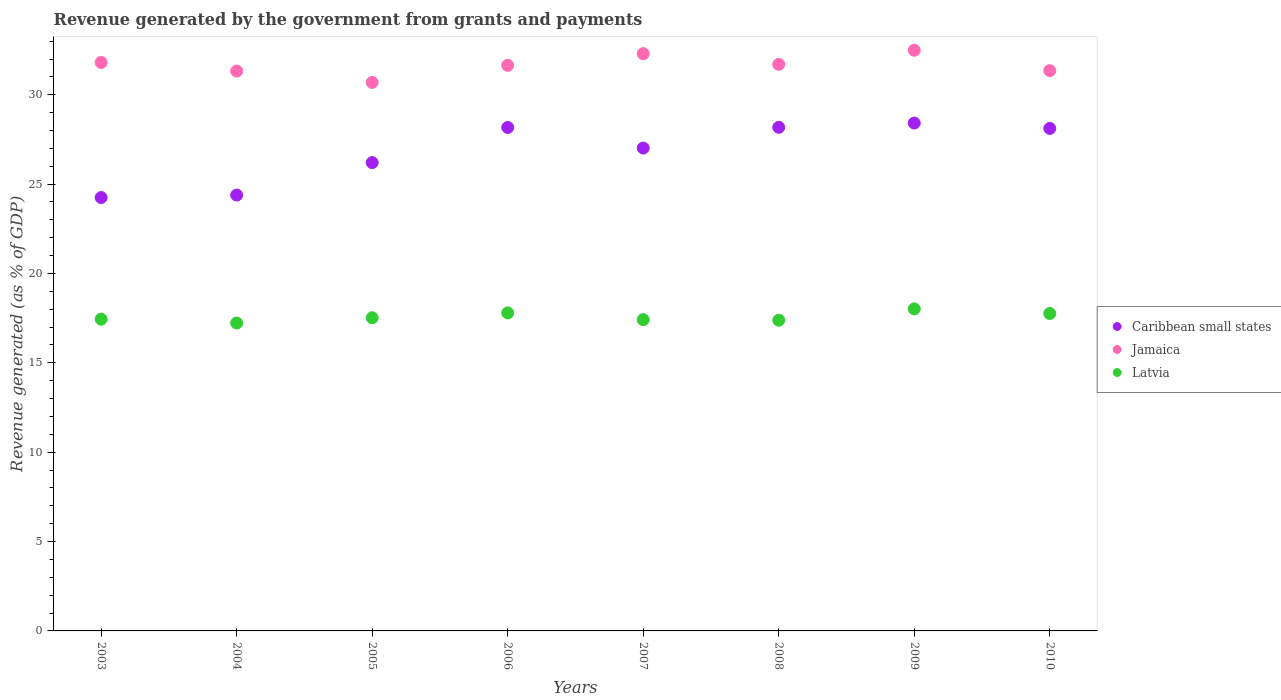How many different coloured dotlines are there?
Provide a short and direct response. 3. What is the revenue generated by the government in Jamaica in 2005?
Your answer should be compact. 30.69. Across all years, what is the maximum revenue generated by the government in Jamaica?
Keep it short and to the point. 32.49. Across all years, what is the minimum revenue generated by the government in Jamaica?
Your answer should be very brief. 30.69. In which year was the revenue generated by the government in Latvia minimum?
Your answer should be very brief. 2004. What is the total revenue generated by the government in Caribbean small states in the graph?
Keep it short and to the point. 214.74. What is the difference between the revenue generated by the government in Jamaica in 2007 and that in 2008?
Make the answer very short. 0.6. What is the difference between the revenue generated by the government in Jamaica in 2004 and the revenue generated by the government in Latvia in 2005?
Your answer should be very brief. 13.8. What is the average revenue generated by the government in Caribbean small states per year?
Your response must be concise. 26.84. In the year 2009, what is the difference between the revenue generated by the government in Caribbean small states and revenue generated by the government in Jamaica?
Make the answer very short. -4.08. What is the ratio of the revenue generated by the government in Latvia in 2005 to that in 2007?
Give a very brief answer. 1.01. Is the revenue generated by the government in Latvia in 2004 less than that in 2010?
Keep it short and to the point. Yes. What is the difference between the highest and the second highest revenue generated by the government in Jamaica?
Give a very brief answer. 0.19. What is the difference between the highest and the lowest revenue generated by the government in Latvia?
Your answer should be compact. 0.79. Does the revenue generated by the government in Latvia monotonically increase over the years?
Provide a succinct answer. No. Is the revenue generated by the government in Jamaica strictly less than the revenue generated by the government in Latvia over the years?
Your answer should be compact. No. Are the values on the major ticks of Y-axis written in scientific E-notation?
Make the answer very short. No. Does the graph contain any zero values?
Give a very brief answer. No. Does the graph contain grids?
Your answer should be very brief. No. Where does the legend appear in the graph?
Keep it short and to the point. Center right. How many legend labels are there?
Offer a very short reply. 3. How are the legend labels stacked?
Keep it short and to the point. Vertical. What is the title of the graph?
Provide a succinct answer. Revenue generated by the government from grants and payments. What is the label or title of the X-axis?
Offer a very short reply. Years. What is the label or title of the Y-axis?
Make the answer very short. Revenue generated (as % of GDP). What is the Revenue generated (as % of GDP) in Caribbean small states in 2003?
Give a very brief answer. 24.25. What is the Revenue generated (as % of GDP) in Jamaica in 2003?
Provide a succinct answer. 31.81. What is the Revenue generated (as % of GDP) of Latvia in 2003?
Offer a terse response. 17.44. What is the Revenue generated (as % of GDP) in Caribbean small states in 2004?
Keep it short and to the point. 24.39. What is the Revenue generated (as % of GDP) in Jamaica in 2004?
Your answer should be very brief. 31.33. What is the Revenue generated (as % of GDP) in Latvia in 2004?
Give a very brief answer. 17.23. What is the Revenue generated (as % of GDP) of Caribbean small states in 2005?
Offer a very short reply. 26.2. What is the Revenue generated (as % of GDP) of Jamaica in 2005?
Offer a very short reply. 30.69. What is the Revenue generated (as % of GDP) of Latvia in 2005?
Offer a terse response. 17.52. What is the Revenue generated (as % of GDP) in Caribbean small states in 2006?
Your answer should be very brief. 28.17. What is the Revenue generated (as % of GDP) in Jamaica in 2006?
Ensure brevity in your answer.  31.65. What is the Revenue generated (as % of GDP) in Latvia in 2006?
Provide a succinct answer. 17.8. What is the Revenue generated (as % of GDP) of Caribbean small states in 2007?
Keep it short and to the point. 27.02. What is the Revenue generated (as % of GDP) in Jamaica in 2007?
Keep it short and to the point. 32.3. What is the Revenue generated (as % of GDP) of Latvia in 2007?
Keep it short and to the point. 17.42. What is the Revenue generated (as % of GDP) of Caribbean small states in 2008?
Ensure brevity in your answer.  28.18. What is the Revenue generated (as % of GDP) in Jamaica in 2008?
Your answer should be compact. 31.7. What is the Revenue generated (as % of GDP) in Latvia in 2008?
Give a very brief answer. 17.38. What is the Revenue generated (as % of GDP) in Caribbean small states in 2009?
Your answer should be very brief. 28.42. What is the Revenue generated (as % of GDP) of Jamaica in 2009?
Give a very brief answer. 32.49. What is the Revenue generated (as % of GDP) of Latvia in 2009?
Give a very brief answer. 18.02. What is the Revenue generated (as % of GDP) in Caribbean small states in 2010?
Keep it short and to the point. 28.12. What is the Revenue generated (as % of GDP) in Jamaica in 2010?
Make the answer very short. 31.35. What is the Revenue generated (as % of GDP) of Latvia in 2010?
Make the answer very short. 17.76. Across all years, what is the maximum Revenue generated (as % of GDP) of Caribbean small states?
Provide a short and direct response. 28.42. Across all years, what is the maximum Revenue generated (as % of GDP) in Jamaica?
Ensure brevity in your answer.  32.49. Across all years, what is the maximum Revenue generated (as % of GDP) of Latvia?
Your answer should be very brief. 18.02. Across all years, what is the minimum Revenue generated (as % of GDP) of Caribbean small states?
Provide a short and direct response. 24.25. Across all years, what is the minimum Revenue generated (as % of GDP) in Jamaica?
Offer a very short reply. 30.69. Across all years, what is the minimum Revenue generated (as % of GDP) in Latvia?
Provide a short and direct response. 17.23. What is the total Revenue generated (as % of GDP) of Caribbean small states in the graph?
Provide a short and direct response. 214.74. What is the total Revenue generated (as % of GDP) of Jamaica in the graph?
Make the answer very short. 253.31. What is the total Revenue generated (as % of GDP) of Latvia in the graph?
Your answer should be compact. 140.57. What is the difference between the Revenue generated (as % of GDP) in Caribbean small states in 2003 and that in 2004?
Provide a short and direct response. -0.14. What is the difference between the Revenue generated (as % of GDP) of Jamaica in 2003 and that in 2004?
Your response must be concise. 0.48. What is the difference between the Revenue generated (as % of GDP) in Latvia in 2003 and that in 2004?
Offer a very short reply. 0.22. What is the difference between the Revenue generated (as % of GDP) in Caribbean small states in 2003 and that in 2005?
Provide a short and direct response. -1.96. What is the difference between the Revenue generated (as % of GDP) of Jamaica in 2003 and that in 2005?
Make the answer very short. 1.12. What is the difference between the Revenue generated (as % of GDP) in Latvia in 2003 and that in 2005?
Provide a short and direct response. -0.08. What is the difference between the Revenue generated (as % of GDP) of Caribbean small states in 2003 and that in 2006?
Offer a terse response. -3.92. What is the difference between the Revenue generated (as % of GDP) of Jamaica in 2003 and that in 2006?
Your answer should be very brief. 0.16. What is the difference between the Revenue generated (as % of GDP) in Latvia in 2003 and that in 2006?
Your answer should be very brief. -0.35. What is the difference between the Revenue generated (as % of GDP) of Caribbean small states in 2003 and that in 2007?
Your answer should be compact. -2.77. What is the difference between the Revenue generated (as % of GDP) of Jamaica in 2003 and that in 2007?
Make the answer very short. -0.49. What is the difference between the Revenue generated (as % of GDP) of Latvia in 2003 and that in 2007?
Give a very brief answer. 0.03. What is the difference between the Revenue generated (as % of GDP) of Caribbean small states in 2003 and that in 2008?
Make the answer very short. -3.93. What is the difference between the Revenue generated (as % of GDP) in Jamaica in 2003 and that in 2008?
Give a very brief answer. 0.11. What is the difference between the Revenue generated (as % of GDP) in Latvia in 2003 and that in 2008?
Your response must be concise. 0.06. What is the difference between the Revenue generated (as % of GDP) in Caribbean small states in 2003 and that in 2009?
Keep it short and to the point. -4.17. What is the difference between the Revenue generated (as % of GDP) of Jamaica in 2003 and that in 2009?
Give a very brief answer. -0.68. What is the difference between the Revenue generated (as % of GDP) in Latvia in 2003 and that in 2009?
Offer a terse response. -0.58. What is the difference between the Revenue generated (as % of GDP) of Caribbean small states in 2003 and that in 2010?
Offer a terse response. -3.87. What is the difference between the Revenue generated (as % of GDP) in Jamaica in 2003 and that in 2010?
Offer a very short reply. 0.46. What is the difference between the Revenue generated (as % of GDP) of Latvia in 2003 and that in 2010?
Offer a very short reply. -0.32. What is the difference between the Revenue generated (as % of GDP) in Caribbean small states in 2004 and that in 2005?
Give a very brief answer. -1.82. What is the difference between the Revenue generated (as % of GDP) of Jamaica in 2004 and that in 2005?
Your answer should be very brief. 0.64. What is the difference between the Revenue generated (as % of GDP) in Latvia in 2004 and that in 2005?
Your answer should be very brief. -0.29. What is the difference between the Revenue generated (as % of GDP) in Caribbean small states in 2004 and that in 2006?
Make the answer very short. -3.78. What is the difference between the Revenue generated (as % of GDP) in Jamaica in 2004 and that in 2006?
Provide a succinct answer. -0.32. What is the difference between the Revenue generated (as % of GDP) of Latvia in 2004 and that in 2006?
Offer a terse response. -0.57. What is the difference between the Revenue generated (as % of GDP) in Caribbean small states in 2004 and that in 2007?
Give a very brief answer. -2.63. What is the difference between the Revenue generated (as % of GDP) of Jamaica in 2004 and that in 2007?
Offer a very short reply. -0.97. What is the difference between the Revenue generated (as % of GDP) in Latvia in 2004 and that in 2007?
Provide a succinct answer. -0.19. What is the difference between the Revenue generated (as % of GDP) of Caribbean small states in 2004 and that in 2008?
Provide a succinct answer. -3.79. What is the difference between the Revenue generated (as % of GDP) of Jamaica in 2004 and that in 2008?
Offer a terse response. -0.38. What is the difference between the Revenue generated (as % of GDP) in Latvia in 2004 and that in 2008?
Keep it short and to the point. -0.16. What is the difference between the Revenue generated (as % of GDP) in Caribbean small states in 2004 and that in 2009?
Provide a succinct answer. -4.03. What is the difference between the Revenue generated (as % of GDP) in Jamaica in 2004 and that in 2009?
Your response must be concise. -1.17. What is the difference between the Revenue generated (as % of GDP) of Latvia in 2004 and that in 2009?
Make the answer very short. -0.79. What is the difference between the Revenue generated (as % of GDP) in Caribbean small states in 2004 and that in 2010?
Your response must be concise. -3.73. What is the difference between the Revenue generated (as % of GDP) in Jamaica in 2004 and that in 2010?
Offer a terse response. -0.02. What is the difference between the Revenue generated (as % of GDP) in Latvia in 2004 and that in 2010?
Your response must be concise. -0.53. What is the difference between the Revenue generated (as % of GDP) of Caribbean small states in 2005 and that in 2006?
Make the answer very short. -1.97. What is the difference between the Revenue generated (as % of GDP) of Jamaica in 2005 and that in 2006?
Provide a succinct answer. -0.96. What is the difference between the Revenue generated (as % of GDP) in Latvia in 2005 and that in 2006?
Make the answer very short. -0.27. What is the difference between the Revenue generated (as % of GDP) of Caribbean small states in 2005 and that in 2007?
Your answer should be compact. -0.81. What is the difference between the Revenue generated (as % of GDP) of Jamaica in 2005 and that in 2007?
Keep it short and to the point. -1.61. What is the difference between the Revenue generated (as % of GDP) of Latvia in 2005 and that in 2007?
Offer a very short reply. 0.1. What is the difference between the Revenue generated (as % of GDP) of Caribbean small states in 2005 and that in 2008?
Provide a short and direct response. -1.97. What is the difference between the Revenue generated (as % of GDP) of Jamaica in 2005 and that in 2008?
Offer a terse response. -1.01. What is the difference between the Revenue generated (as % of GDP) in Latvia in 2005 and that in 2008?
Your answer should be compact. 0.14. What is the difference between the Revenue generated (as % of GDP) of Caribbean small states in 2005 and that in 2009?
Make the answer very short. -2.21. What is the difference between the Revenue generated (as % of GDP) of Jamaica in 2005 and that in 2009?
Your answer should be very brief. -1.8. What is the difference between the Revenue generated (as % of GDP) in Latvia in 2005 and that in 2009?
Your response must be concise. -0.5. What is the difference between the Revenue generated (as % of GDP) of Caribbean small states in 2005 and that in 2010?
Your response must be concise. -1.91. What is the difference between the Revenue generated (as % of GDP) in Jamaica in 2005 and that in 2010?
Provide a succinct answer. -0.66. What is the difference between the Revenue generated (as % of GDP) in Latvia in 2005 and that in 2010?
Ensure brevity in your answer.  -0.24. What is the difference between the Revenue generated (as % of GDP) in Caribbean small states in 2006 and that in 2007?
Your answer should be compact. 1.15. What is the difference between the Revenue generated (as % of GDP) in Jamaica in 2006 and that in 2007?
Your response must be concise. -0.65. What is the difference between the Revenue generated (as % of GDP) in Latvia in 2006 and that in 2007?
Provide a short and direct response. 0.38. What is the difference between the Revenue generated (as % of GDP) in Caribbean small states in 2006 and that in 2008?
Provide a succinct answer. -0.01. What is the difference between the Revenue generated (as % of GDP) in Jamaica in 2006 and that in 2008?
Ensure brevity in your answer.  -0.06. What is the difference between the Revenue generated (as % of GDP) in Latvia in 2006 and that in 2008?
Ensure brevity in your answer.  0.41. What is the difference between the Revenue generated (as % of GDP) of Caribbean small states in 2006 and that in 2009?
Make the answer very short. -0.25. What is the difference between the Revenue generated (as % of GDP) of Jamaica in 2006 and that in 2009?
Make the answer very short. -0.85. What is the difference between the Revenue generated (as % of GDP) of Latvia in 2006 and that in 2009?
Offer a very short reply. -0.22. What is the difference between the Revenue generated (as % of GDP) in Caribbean small states in 2006 and that in 2010?
Keep it short and to the point. 0.05. What is the difference between the Revenue generated (as % of GDP) of Jamaica in 2006 and that in 2010?
Keep it short and to the point. 0.3. What is the difference between the Revenue generated (as % of GDP) of Latvia in 2006 and that in 2010?
Ensure brevity in your answer.  0.03. What is the difference between the Revenue generated (as % of GDP) of Caribbean small states in 2007 and that in 2008?
Your answer should be very brief. -1.16. What is the difference between the Revenue generated (as % of GDP) in Jamaica in 2007 and that in 2008?
Give a very brief answer. 0.6. What is the difference between the Revenue generated (as % of GDP) in Latvia in 2007 and that in 2008?
Your answer should be very brief. 0.03. What is the difference between the Revenue generated (as % of GDP) in Caribbean small states in 2007 and that in 2009?
Offer a terse response. -1.4. What is the difference between the Revenue generated (as % of GDP) of Jamaica in 2007 and that in 2009?
Keep it short and to the point. -0.19. What is the difference between the Revenue generated (as % of GDP) in Latvia in 2007 and that in 2009?
Ensure brevity in your answer.  -0.6. What is the difference between the Revenue generated (as % of GDP) in Caribbean small states in 2007 and that in 2010?
Make the answer very short. -1.1. What is the difference between the Revenue generated (as % of GDP) in Jamaica in 2007 and that in 2010?
Your response must be concise. 0.95. What is the difference between the Revenue generated (as % of GDP) of Latvia in 2007 and that in 2010?
Offer a terse response. -0.35. What is the difference between the Revenue generated (as % of GDP) in Caribbean small states in 2008 and that in 2009?
Provide a succinct answer. -0.24. What is the difference between the Revenue generated (as % of GDP) of Jamaica in 2008 and that in 2009?
Offer a terse response. -0.79. What is the difference between the Revenue generated (as % of GDP) in Latvia in 2008 and that in 2009?
Offer a terse response. -0.64. What is the difference between the Revenue generated (as % of GDP) of Caribbean small states in 2008 and that in 2010?
Provide a short and direct response. 0.06. What is the difference between the Revenue generated (as % of GDP) of Jamaica in 2008 and that in 2010?
Keep it short and to the point. 0.35. What is the difference between the Revenue generated (as % of GDP) of Latvia in 2008 and that in 2010?
Ensure brevity in your answer.  -0.38. What is the difference between the Revenue generated (as % of GDP) in Caribbean small states in 2009 and that in 2010?
Your answer should be compact. 0.3. What is the difference between the Revenue generated (as % of GDP) in Jamaica in 2009 and that in 2010?
Your answer should be very brief. 1.14. What is the difference between the Revenue generated (as % of GDP) in Latvia in 2009 and that in 2010?
Provide a succinct answer. 0.26. What is the difference between the Revenue generated (as % of GDP) in Caribbean small states in 2003 and the Revenue generated (as % of GDP) in Jamaica in 2004?
Provide a succinct answer. -7.08. What is the difference between the Revenue generated (as % of GDP) of Caribbean small states in 2003 and the Revenue generated (as % of GDP) of Latvia in 2004?
Give a very brief answer. 7.02. What is the difference between the Revenue generated (as % of GDP) of Jamaica in 2003 and the Revenue generated (as % of GDP) of Latvia in 2004?
Provide a short and direct response. 14.58. What is the difference between the Revenue generated (as % of GDP) in Caribbean small states in 2003 and the Revenue generated (as % of GDP) in Jamaica in 2005?
Your response must be concise. -6.44. What is the difference between the Revenue generated (as % of GDP) of Caribbean small states in 2003 and the Revenue generated (as % of GDP) of Latvia in 2005?
Provide a short and direct response. 6.73. What is the difference between the Revenue generated (as % of GDP) in Jamaica in 2003 and the Revenue generated (as % of GDP) in Latvia in 2005?
Your answer should be compact. 14.29. What is the difference between the Revenue generated (as % of GDP) in Caribbean small states in 2003 and the Revenue generated (as % of GDP) in Jamaica in 2006?
Give a very brief answer. -7.4. What is the difference between the Revenue generated (as % of GDP) in Caribbean small states in 2003 and the Revenue generated (as % of GDP) in Latvia in 2006?
Make the answer very short. 6.45. What is the difference between the Revenue generated (as % of GDP) of Jamaica in 2003 and the Revenue generated (as % of GDP) of Latvia in 2006?
Your response must be concise. 14.01. What is the difference between the Revenue generated (as % of GDP) in Caribbean small states in 2003 and the Revenue generated (as % of GDP) in Jamaica in 2007?
Provide a short and direct response. -8.05. What is the difference between the Revenue generated (as % of GDP) in Caribbean small states in 2003 and the Revenue generated (as % of GDP) in Latvia in 2007?
Offer a terse response. 6.83. What is the difference between the Revenue generated (as % of GDP) of Jamaica in 2003 and the Revenue generated (as % of GDP) of Latvia in 2007?
Ensure brevity in your answer.  14.39. What is the difference between the Revenue generated (as % of GDP) in Caribbean small states in 2003 and the Revenue generated (as % of GDP) in Jamaica in 2008?
Offer a terse response. -7.45. What is the difference between the Revenue generated (as % of GDP) of Caribbean small states in 2003 and the Revenue generated (as % of GDP) of Latvia in 2008?
Provide a succinct answer. 6.86. What is the difference between the Revenue generated (as % of GDP) of Jamaica in 2003 and the Revenue generated (as % of GDP) of Latvia in 2008?
Provide a succinct answer. 14.42. What is the difference between the Revenue generated (as % of GDP) in Caribbean small states in 2003 and the Revenue generated (as % of GDP) in Jamaica in 2009?
Provide a succinct answer. -8.24. What is the difference between the Revenue generated (as % of GDP) in Caribbean small states in 2003 and the Revenue generated (as % of GDP) in Latvia in 2009?
Your answer should be very brief. 6.23. What is the difference between the Revenue generated (as % of GDP) of Jamaica in 2003 and the Revenue generated (as % of GDP) of Latvia in 2009?
Provide a short and direct response. 13.79. What is the difference between the Revenue generated (as % of GDP) in Caribbean small states in 2003 and the Revenue generated (as % of GDP) in Jamaica in 2010?
Give a very brief answer. -7.1. What is the difference between the Revenue generated (as % of GDP) in Caribbean small states in 2003 and the Revenue generated (as % of GDP) in Latvia in 2010?
Offer a terse response. 6.49. What is the difference between the Revenue generated (as % of GDP) in Jamaica in 2003 and the Revenue generated (as % of GDP) in Latvia in 2010?
Make the answer very short. 14.05. What is the difference between the Revenue generated (as % of GDP) of Caribbean small states in 2004 and the Revenue generated (as % of GDP) of Jamaica in 2005?
Keep it short and to the point. -6.3. What is the difference between the Revenue generated (as % of GDP) of Caribbean small states in 2004 and the Revenue generated (as % of GDP) of Latvia in 2005?
Your answer should be very brief. 6.87. What is the difference between the Revenue generated (as % of GDP) in Jamaica in 2004 and the Revenue generated (as % of GDP) in Latvia in 2005?
Your answer should be very brief. 13.8. What is the difference between the Revenue generated (as % of GDP) in Caribbean small states in 2004 and the Revenue generated (as % of GDP) in Jamaica in 2006?
Make the answer very short. -7.26. What is the difference between the Revenue generated (as % of GDP) of Caribbean small states in 2004 and the Revenue generated (as % of GDP) of Latvia in 2006?
Keep it short and to the point. 6.59. What is the difference between the Revenue generated (as % of GDP) in Jamaica in 2004 and the Revenue generated (as % of GDP) in Latvia in 2006?
Your response must be concise. 13.53. What is the difference between the Revenue generated (as % of GDP) of Caribbean small states in 2004 and the Revenue generated (as % of GDP) of Jamaica in 2007?
Your answer should be compact. -7.91. What is the difference between the Revenue generated (as % of GDP) in Caribbean small states in 2004 and the Revenue generated (as % of GDP) in Latvia in 2007?
Give a very brief answer. 6.97. What is the difference between the Revenue generated (as % of GDP) in Jamaica in 2004 and the Revenue generated (as % of GDP) in Latvia in 2007?
Make the answer very short. 13.91. What is the difference between the Revenue generated (as % of GDP) in Caribbean small states in 2004 and the Revenue generated (as % of GDP) in Jamaica in 2008?
Make the answer very short. -7.31. What is the difference between the Revenue generated (as % of GDP) in Caribbean small states in 2004 and the Revenue generated (as % of GDP) in Latvia in 2008?
Your answer should be compact. 7. What is the difference between the Revenue generated (as % of GDP) of Jamaica in 2004 and the Revenue generated (as % of GDP) of Latvia in 2008?
Provide a succinct answer. 13.94. What is the difference between the Revenue generated (as % of GDP) of Caribbean small states in 2004 and the Revenue generated (as % of GDP) of Jamaica in 2009?
Keep it short and to the point. -8.1. What is the difference between the Revenue generated (as % of GDP) of Caribbean small states in 2004 and the Revenue generated (as % of GDP) of Latvia in 2009?
Give a very brief answer. 6.37. What is the difference between the Revenue generated (as % of GDP) in Jamaica in 2004 and the Revenue generated (as % of GDP) in Latvia in 2009?
Provide a succinct answer. 13.31. What is the difference between the Revenue generated (as % of GDP) of Caribbean small states in 2004 and the Revenue generated (as % of GDP) of Jamaica in 2010?
Give a very brief answer. -6.96. What is the difference between the Revenue generated (as % of GDP) in Caribbean small states in 2004 and the Revenue generated (as % of GDP) in Latvia in 2010?
Your answer should be very brief. 6.63. What is the difference between the Revenue generated (as % of GDP) in Jamaica in 2004 and the Revenue generated (as % of GDP) in Latvia in 2010?
Make the answer very short. 13.56. What is the difference between the Revenue generated (as % of GDP) of Caribbean small states in 2005 and the Revenue generated (as % of GDP) of Jamaica in 2006?
Offer a very short reply. -5.44. What is the difference between the Revenue generated (as % of GDP) of Caribbean small states in 2005 and the Revenue generated (as % of GDP) of Latvia in 2006?
Provide a short and direct response. 8.41. What is the difference between the Revenue generated (as % of GDP) of Jamaica in 2005 and the Revenue generated (as % of GDP) of Latvia in 2006?
Make the answer very short. 12.89. What is the difference between the Revenue generated (as % of GDP) in Caribbean small states in 2005 and the Revenue generated (as % of GDP) in Jamaica in 2007?
Your answer should be compact. -6.1. What is the difference between the Revenue generated (as % of GDP) of Caribbean small states in 2005 and the Revenue generated (as % of GDP) of Latvia in 2007?
Keep it short and to the point. 8.79. What is the difference between the Revenue generated (as % of GDP) in Jamaica in 2005 and the Revenue generated (as % of GDP) in Latvia in 2007?
Keep it short and to the point. 13.27. What is the difference between the Revenue generated (as % of GDP) in Caribbean small states in 2005 and the Revenue generated (as % of GDP) in Jamaica in 2008?
Offer a very short reply. -5.5. What is the difference between the Revenue generated (as % of GDP) of Caribbean small states in 2005 and the Revenue generated (as % of GDP) of Latvia in 2008?
Keep it short and to the point. 8.82. What is the difference between the Revenue generated (as % of GDP) in Jamaica in 2005 and the Revenue generated (as % of GDP) in Latvia in 2008?
Offer a terse response. 13.31. What is the difference between the Revenue generated (as % of GDP) in Caribbean small states in 2005 and the Revenue generated (as % of GDP) in Jamaica in 2009?
Offer a terse response. -6.29. What is the difference between the Revenue generated (as % of GDP) in Caribbean small states in 2005 and the Revenue generated (as % of GDP) in Latvia in 2009?
Your response must be concise. 8.18. What is the difference between the Revenue generated (as % of GDP) in Jamaica in 2005 and the Revenue generated (as % of GDP) in Latvia in 2009?
Offer a very short reply. 12.67. What is the difference between the Revenue generated (as % of GDP) of Caribbean small states in 2005 and the Revenue generated (as % of GDP) of Jamaica in 2010?
Keep it short and to the point. -5.14. What is the difference between the Revenue generated (as % of GDP) in Caribbean small states in 2005 and the Revenue generated (as % of GDP) in Latvia in 2010?
Ensure brevity in your answer.  8.44. What is the difference between the Revenue generated (as % of GDP) in Jamaica in 2005 and the Revenue generated (as % of GDP) in Latvia in 2010?
Your answer should be very brief. 12.93. What is the difference between the Revenue generated (as % of GDP) of Caribbean small states in 2006 and the Revenue generated (as % of GDP) of Jamaica in 2007?
Keep it short and to the point. -4.13. What is the difference between the Revenue generated (as % of GDP) in Caribbean small states in 2006 and the Revenue generated (as % of GDP) in Latvia in 2007?
Offer a terse response. 10.75. What is the difference between the Revenue generated (as % of GDP) in Jamaica in 2006 and the Revenue generated (as % of GDP) in Latvia in 2007?
Your response must be concise. 14.23. What is the difference between the Revenue generated (as % of GDP) in Caribbean small states in 2006 and the Revenue generated (as % of GDP) in Jamaica in 2008?
Provide a succinct answer. -3.53. What is the difference between the Revenue generated (as % of GDP) of Caribbean small states in 2006 and the Revenue generated (as % of GDP) of Latvia in 2008?
Keep it short and to the point. 10.79. What is the difference between the Revenue generated (as % of GDP) in Jamaica in 2006 and the Revenue generated (as % of GDP) in Latvia in 2008?
Your response must be concise. 14.26. What is the difference between the Revenue generated (as % of GDP) in Caribbean small states in 2006 and the Revenue generated (as % of GDP) in Jamaica in 2009?
Provide a short and direct response. -4.32. What is the difference between the Revenue generated (as % of GDP) in Caribbean small states in 2006 and the Revenue generated (as % of GDP) in Latvia in 2009?
Ensure brevity in your answer.  10.15. What is the difference between the Revenue generated (as % of GDP) of Jamaica in 2006 and the Revenue generated (as % of GDP) of Latvia in 2009?
Offer a terse response. 13.63. What is the difference between the Revenue generated (as % of GDP) in Caribbean small states in 2006 and the Revenue generated (as % of GDP) in Jamaica in 2010?
Offer a very short reply. -3.18. What is the difference between the Revenue generated (as % of GDP) in Caribbean small states in 2006 and the Revenue generated (as % of GDP) in Latvia in 2010?
Your answer should be compact. 10.41. What is the difference between the Revenue generated (as % of GDP) of Jamaica in 2006 and the Revenue generated (as % of GDP) of Latvia in 2010?
Provide a short and direct response. 13.88. What is the difference between the Revenue generated (as % of GDP) of Caribbean small states in 2007 and the Revenue generated (as % of GDP) of Jamaica in 2008?
Make the answer very short. -4.68. What is the difference between the Revenue generated (as % of GDP) in Caribbean small states in 2007 and the Revenue generated (as % of GDP) in Latvia in 2008?
Your answer should be compact. 9.63. What is the difference between the Revenue generated (as % of GDP) of Jamaica in 2007 and the Revenue generated (as % of GDP) of Latvia in 2008?
Offer a very short reply. 14.91. What is the difference between the Revenue generated (as % of GDP) in Caribbean small states in 2007 and the Revenue generated (as % of GDP) in Jamaica in 2009?
Provide a short and direct response. -5.47. What is the difference between the Revenue generated (as % of GDP) of Caribbean small states in 2007 and the Revenue generated (as % of GDP) of Latvia in 2009?
Provide a short and direct response. 9. What is the difference between the Revenue generated (as % of GDP) of Jamaica in 2007 and the Revenue generated (as % of GDP) of Latvia in 2009?
Make the answer very short. 14.28. What is the difference between the Revenue generated (as % of GDP) of Caribbean small states in 2007 and the Revenue generated (as % of GDP) of Jamaica in 2010?
Your answer should be very brief. -4.33. What is the difference between the Revenue generated (as % of GDP) of Caribbean small states in 2007 and the Revenue generated (as % of GDP) of Latvia in 2010?
Your response must be concise. 9.26. What is the difference between the Revenue generated (as % of GDP) in Jamaica in 2007 and the Revenue generated (as % of GDP) in Latvia in 2010?
Make the answer very short. 14.54. What is the difference between the Revenue generated (as % of GDP) of Caribbean small states in 2008 and the Revenue generated (as % of GDP) of Jamaica in 2009?
Your response must be concise. -4.31. What is the difference between the Revenue generated (as % of GDP) in Caribbean small states in 2008 and the Revenue generated (as % of GDP) in Latvia in 2009?
Make the answer very short. 10.16. What is the difference between the Revenue generated (as % of GDP) in Jamaica in 2008 and the Revenue generated (as % of GDP) in Latvia in 2009?
Provide a short and direct response. 13.68. What is the difference between the Revenue generated (as % of GDP) of Caribbean small states in 2008 and the Revenue generated (as % of GDP) of Jamaica in 2010?
Keep it short and to the point. -3.17. What is the difference between the Revenue generated (as % of GDP) in Caribbean small states in 2008 and the Revenue generated (as % of GDP) in Latvia in 2010?
Offer a very short reply. 10.42. What is the difference between the Revenue generated (as % of GDP) of Jamaica in 2008 and the Revenue generated (as % of GDP) of Latvia in 2010?
Your answer should be compact. 13.94. What is the difference between the Revenue generated (as % of GDP) of Caribbean small states in 2009 and the Revenue generated (as % of GDP) of Jamaica in 2010?
Your answer should be very brief. -2.93. What is the difference between the Revenue generated (as % of GDP) of Caribbean small states in 2009 and the Revenue generated (as % of GDP) of Latvia in 2010?
Your response must be concise. 10.65. What is the difference between the Revenue generated (as % of GDP) in Jamaica in 2009 and the Revenue generated (as % of GDP) in Latvia in 2010?
Ensure brevity in your answer.  14.73. What is the average Revenue generated (as % of GDP) of Caribbean small states per year?
Offer a terse response. 26.84. What is the average Revenue generated (as % of GDP) in Jamaica per year?
Your answer should be very brief. 31.66. What is the average Revenue generated (as % of GDP) in Latvia per year?
Keep it short and to the point. 17.57. In the year 2003, what is the difference between the Revenue generated (as % of GDP) in Caribbean small states and Revenue generated (as % of GDP) in Jamaica?
Your response must be concise. -7.56. In the year 2003, what is the difference between the Revenue generated (as % of GDP) in Caribbean small states and Revenue generated (as % of GDP) in Latvia?
Your response must be concise. 6.8. In the year 2003, what is the difference between the Revenue generated (as % of GDP) of Jamaica and Revenue generated (as % of GDP) of Latvia?
Provide a succinct answer. 14.36. In the year 2004, what is the difference between the Revenue generated (as % of GDP) of Caribbean small states and Revenue generated (as % of GDP) of Jamaica?
Your response must be concise. -6.94. In the year 2004, what is the difference between the Revenue generated (as % of GDP) in Caribbean small states and Revenue generated (as % of GDP) in Latvia?
Your response must be concise. 7.16. In the year 2004, what is the difference between the Revenue generated (as % of GDP) of Jamaica and Revenue generated (as % of GDP) of Latvia?
Ensure brevity in your answer.  14.1. In the year 2005, what is the difference between the Revenue generated (as % of GDP) of Caribbean small states and Revenue generated (as % of GDP) of Jamaica?
Keep it short and to the point. -4.49. In the year 2005, what is the difference between the Revenue generated (as % of GDP) of Caribbean small states and Revenue generated (as % of GDP) of Latvia?
Provide a succinct answer. 8.68. In the year 2005, what is the difference between the Revenue generated (as % of GDP) of Jamaica and Revenue generated (as % of GDP) of Latvia?
Give a very brief answer. 13.17. In the year 2006, what is the difference between the Revenue generated (as % of GDP) in Caribbean small states and Revenue generated (as % of GDP) in Jamaica?
Your response must be concise. -3.48. In the year 2006, what is the difference between the Revenue generated (as % of GDP) in Caribbean small states and Revenue generated (as % of GDP) in Latvia?
Make the answer very short. 10.38. In the year 2006, what is the difference between the Revenue generated (as % of GDP) in Jamaica and Revenue generated (as % of GDP) in Latvia?
Your answer should be very brief. 13.85. In the year 2007, what is the difference between the Revenue generated (as % of GDP) of Caribbean small states and Revenue generated (as % of GDP) of Jamaica?
Keep it short and to the point. -5.28. In the year 2007, what is the difference between the Revenue generated (as % of GDP) in Caribbean small states and Revenue generated (as % of GDP) in Latvia?
Offer a terse response. 9.6. In the year 2007, what is the difference between the Revenue generated (as % of GDP) of Jamaica and Revenue generated (as % of GDP) of Latvia?
Your answer should be compact. 14.88. In the year 2008, what is the difference between the Revenue generated (as % of GDP) in Caribbean small states and Revenue generated (as % of GDP) in Jamaica?
Your answer should be compact. -3.52. In the year 2008, what is the difference between the Revenue generated (as % of GDP) of Caribbean small states and Revenue generated (as % of GDP) of Latvia?
Make the answer very short. 10.79. In the year 2008, what is the difference between the Revenue generated (as % of GDP) of Jamaica and Revenue generated (as % of GDP) of Latvia?
Your answer should be compact. 14.32. In the year 2009, what is the difference between the Revenue generated (as % of GDP) of Caribbean small states and Revenue generated (as % of GDP) of Jamaica?
Offer a terse response. -4.08. In the year 2009, what is the difference between the Revenue generated (as % of GDP) of Caribbean small states and Revenue generated (as % of GDP) of Latvia?
Your response must be concise. 10.4. In the year 2009, what is the difference between the Revenue generated (as % of GDP) of Jamaica and Revenue generated (as % of GDP) of Latvia?
Give a very brief answer. 14.47. In the year 2010, what is the difference between the Revenue generated (as % of GDP) in Caribbean small states and Revenue generated (as % of GDP) in Jamaica?
Offer a terse response. -3.23. In the year 2010, what is the difference between the Revenue generated (as % of GDP) in Caribbean small states and Revenue generated (as % of GDP) in Latvia?
Provide a succinct answer. 10.35. In the year 2010, what is the difference between the Revenue generated (as % of GDP) of Jamaica and Revenue generated (as % of GDP) of Latvia?
Provide a short and direct response. 13.59. What is the ratio of the Revenue generated (as % of GDP) in Jamaica in 2003 to that in 2004?
Offer a very short reply. 1.02. What is the ratio of the Revenue generated (as % of GDP) of Latvia in 2003 to that in 2004?
Keep it short and to the point. 1.01. What is the ratio of the Revenue generated (as % of GDP) in Caribbean small states in 2003 to that in 2005?
Give a very brief answer. 0.93. What is the ratio of the Revenue generated (as % of GDP) of Jamaica in 2003 to that in 2005?
Offer a terse response. 1.04. What is the ratio of the Revenue generated (as % of GDP) of Caribbean small states in 2003 to that in 2006?
Provide a succinct answer. 0.86. What is the ratio of the Revenue generated (as % of GDP) in Latvia in 2003 to that in 2006?
Your answer should be compact. 0.98. What is the ratio of the Revenue generated (as % of GDP) of Caribbean small states in 2003 to that in 2007?
Provide a succinct answer. 0.9. What is the ratio of the Revenue generated (as % of GDP) of Caribbean small states in 2003 to that in 2008?
Your answer should be compact. 0.86. What is the ratio of the Revenue generated (as % of GDP) of Latvia in 2003 to that in 2008?
Make the answer very short. 1. What is the ratio of the Revenue generated (as % of GDP) in Caribbean small states in 2003 to that in 2009?
Your response must be concise. 0.85. What is the ratio of the Revenue generated (as % of GDP) in Jamaica in 2003 to that in 2009?
Keep it short and to the point. 0.98. What is the ratio of the Revenue generated (as % of GDP) in Caribbean small states in 2003 to that in 2010?
Offer a very short reply. 0.86. What is the ratio of the Revenue generated (as % of GDP) in Jamaica in 2003 to that in 2010?
Ensure brevity in your answer.  1.01. What is the ratio of the Revenue generated (as % of GDP) of Latvia in 2003 to that in 2010?
Keep it short and to the point. 0.98. What is the ratio of the Revenue generated (as % of GDP) of Caribbean small states in 2004 to that in 2005?
Give a very brief answer. 0.93. What is the ratio of the Revenue generated (as % of GDP) in Jamaica in 2004 to that in 2005?
Provide a succinct answer. 1.02. What is the ratio of the Revenue generated (as % of GDP) in Latvia in 2004 to that in 2005?
Give a very brief answer. 0.98. What is the ratio of the Revenue generated (as % of GDP) of Caribbean small states in 2004 to that in 2006?
Ensure brevity in your answer.  0.87. What is the ratio of the Revenue generated (as % of GDP) of Latvia in 2004 to that in 2006?
Provide a succinct answer. 0.97. What is the ratio of the Revenue generated (as % of GDP) of Caribbean small states in 2004 to that in 2007?
Keep it short and to the point. 0.9. What is the ratio of the Revenue generated (as % of GDP) of Jamaica in 2004 to that in 2007?
Give a very brief answer. 0.97. What is the ratio of the Revenue generated (as % of GDP) in Caribbean small states in 2004 to that in 2008?
Offer a terse response. 0.87. What is the ratio of the Revenue generated (as % of GDP) of Jamaica in 2004 to that in 2008?
Make the answer very short. 0.99. What is the ratio of the Revenue generated (as % of GDP) of Caribbean small states in 2004 to that in 2009?
Ensure brevity in your answer.  0.86. What is the ratio of the Revenue generated (as % of GDP) in Jamaica in 2004 to that in 2009?
Provide a succinct answer. 0.96. What is the ratio of the Revenue generated (as % of GDP) of Latvia in 2004 to that in 2009?
Offer a terse response. 0.96. What is the ratio of the Revenue generated (as % of GDP) of Caribbean small states in 2004 to that in 2010?
Give a very brief answer. 0.87. What is the ratio of the Revenue generated (as % of GDP) of Latvia in 2004 to that in 2010?
Your answer should be compact. 0.97. What is the ratio of the Revenue generated (as % of GDP) of Caribbean small states in 2005 to that in 2006?
Make the answer very short. 0.93. What is the ratio of the Revenue generated (as % of GDP) in Jamaica in 2005 to that in 2006?
Keep it short and to the point. 0.97. What is the ratio of the Revenue generated (as % of GDP) in Latvia in 2005 to that in 2006?
Provide a succinct answer. 0.98. What is the ratio of the Revenue generated (as % of GDP) of Caribbean small states in 2005 to that in 2007?
Offer a terse response. 0.97. What is the ratio of the Revenue generated (as % of GDP) of Jamaica in 2005 to that in 2007?
Make the answer very short. 0.95. What is the ratio of the Revenue generated (as % of GDP) of Latvia in 2005 to that in 2007?
Ensure brevity in your answer.  1.01. What is the ratio of the Revenue generated (as % of GDP) of Caribbean small states in 2005 to that in 2008?
Ensure brevity in your answer.  0.93. What is the ratio of the Revenue generated (as % of GDP) in Jamaica in 2005 to that in 2008?
Make the answer very short. 0.97. What is the ratio of the Revenue generated (as % of GDP) of Latvia in 2005 to that in 2008?
Make the answer very short. 1.01. What is the ratio of the Revenue generated (as % of GDP) in Caribbean small states in 2005 to that in 2009?
Make the answer very short. 0.92. What is the ratio of the Revenue generated (as % of GDP) in Jamaica in 2005 to that in 2009?
Provide a succinct answer. 0.94. What is the ratio of the Revenue generated (as % of GDP) in Latvia in 2005 to that in 2009?
Your response must be concise. 0.97. What is the ratio of the Revenue generated (as % of GDP) of Caribbean small states in 2005 to that in 2010?
Provide a short and direct response. 0.93. What is the ratio of the Revenue generated (as % of GDP) in Jamaica in 2005 to that in 2010?
Your answer should be compact. 0.98. What is the ratio of the Revenue generated (as % of GDP) of Latvia in 2005 to that in 2010?
Provide a succinct answer. 0.99. What is the ratio of the Revenue generated (as % of GDP) in Caribbean small states in 2006 to that in 2007?
Your answer should be very brief. 1.04. What is the ratio of the Revenue generated (as % of GDP) in Jamaica in 2006 to that in 2007?
Your answer should be very brief. 0.98. What is the ratio of the Revenue generated (as % of GDP) of Latvia in 2006 to that in 2007?
Your answer should be compact. 1.02. What is the ratio of the Revenue generated (as % of GDP) in Caribbean small states in 2006 to that in 2008?
Provide a succinct answer. 1. What is the ratio of the Revenue generated (as % of GDP) of Latvia in 2006 to that in 2008?
Your response must be concise. 1.02. What is the ratio of the Revenue generated (as % of GDP) of Caribbean small states in 2006 to that in 2009?
Your answer should be very brief. 0.99. What is the ratio of the Revenue generated (as % of GDP) of Jamaica in 2006 to that in 2009?
Offer a very short reply. 0.97. What is the ratio of the Revenue generated (as % of GDP) in Latvia in 2006 to that in 2009?
Give a very brief answer. 0.99. What is the ratio of the Revenue generated (as % of GDP) of Jamaica in 2006 to that in 2010?
Offer a terse response. 1.01. What is the ratio of the Revenue generated (as % of GDP) in Caribbean small states in 2007 to that in 2008?
Your response must be concise. 0.96. What is the ratio of the Revenue generated (as % of GDP) of Jamaica in 2007 to that in 2008?
Provide a succinct answer. 1.02. What is the ratio of the Revenue generated (as % of GDP) in Latvia in 2007 to that in 2008?
Your answer should be very brief. 1. What is the ratio of the Revenue generated (as % of GDP) of Caribbean small states in 2007 to that in 2009?
Ensure brevity in your answer.  0.95. What is the ratio of the Revenue generated (as % of GDP) in Jamaica in 2007 to that in 2009?
Keep it short and to the point. 0.99. What is the ratio of the Revenue generated (as % of GDP) of Latvia in 2007 to that in 2009?
Give a very brief answer. 0.97. What is the ratio of the Revenue generated (as % of GDP) in Jamaica in 2007 to that in 2010?
Provide a short and direct response. 1.03. What is the ratio of the Revenue generated (as % of GDP) of Latvia in 2007 to that in 2010?
Provide a succinct answer. 0.98. What is the ratio of the Revenue generated (as % of GDP) in Jamaica in 2008 to that in 2009?
Your answer should be very brief. 0.98. What is the ratio of the Revenue generated (as % of GDP) of Latvia in 2008 to that in 2009?
Provide a succinct answer. 0.96. What is the ratio of the Revenue generated (as % of GDP) of Caribbean small states in 2008 to that in 2010?
Your answer should be very brief. 1. What is the ratio of the Revenue generated (as % of GDP) in Jamaica in 2008 to that in 2010?
Ensure brevity in your answer.  1.01. What is the ratio of the Revenue generated (as % of GDP) of Latvia in 2008 to that in 2010?
Ensure brevity in your answer.  0.98. What is the ratio of the Revenue generated (as % of GDP) of Caribbean small states in 2009 to that in 2010?
Your answer should be very brief. 1.01. What is the ratio of the Revenue generated (as % of GDP) of Jamaica in 2009 to that in 2010?
Your response must be concise. 1.04. What is the ratio of the Revenue generated (as % of GDP) in Latvia in 2009 to that in 2010?
Make the answer very short. 1.01. What is the difference between the highest and the second highest Revenue generated (as % of GDP) in Caribbean small states?
Provide a succinct answer. 0.24. What is the difference between the highest and the second highest Revenue generated (as % of GDP) in Jamaica?
Your response must be concise. 0.19. What is the difference between the highest and the second highest Revenue generated (as % of GDP) of Latvia?
Ensure brevity in your answer.  0.22. What is the difference between the highest and the lowest Revenue generated (as % of GDP) of Caribbean small states?
Offer a very short reply. 4.17. What is the difference between the highest and the lowest Revenue generated (as % of GDP) in Jamaica?
Offer a terse response. 1.8. What is the difference between the highest and the lowest Revenue generated (as % of GDP) in Latvia?
Your answer should be very brief. 0.79. 